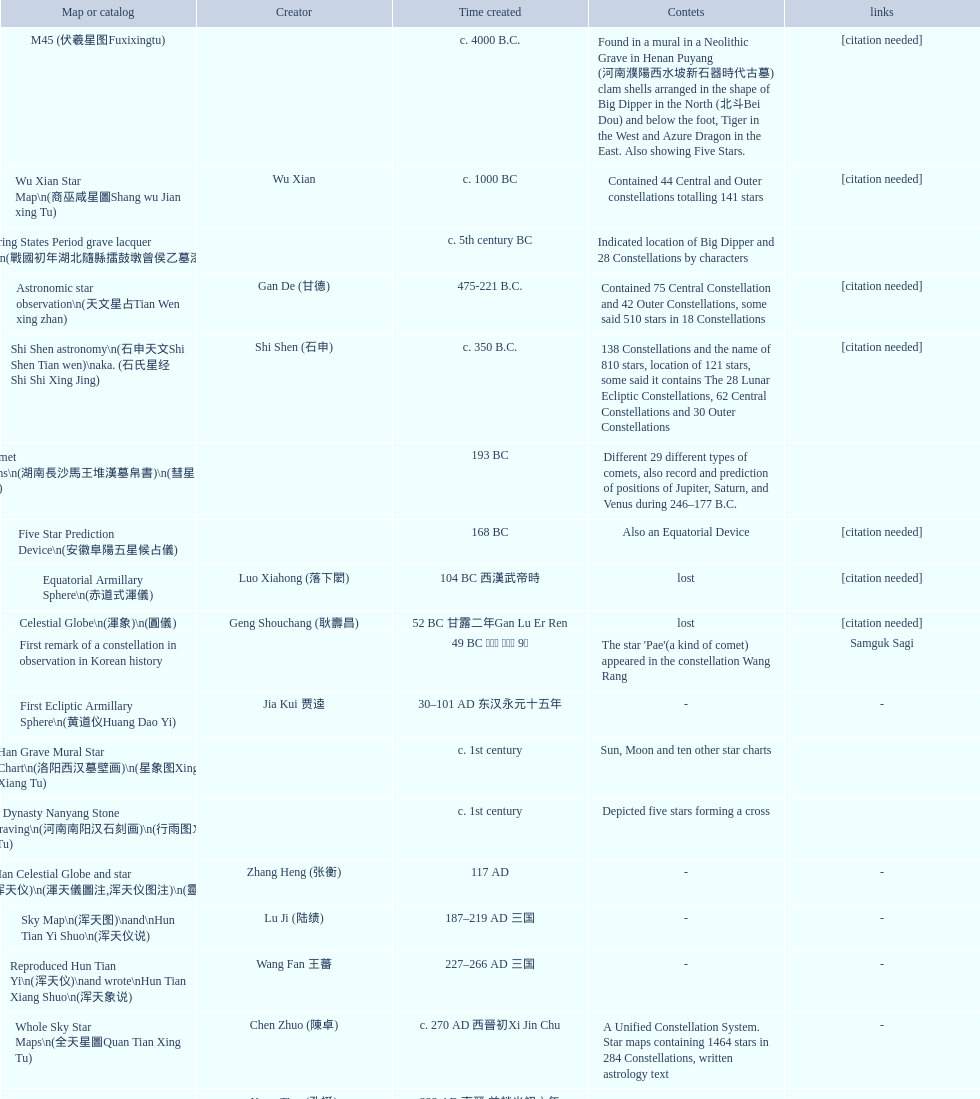Mention three products developed closely following the equatorial armillary sphere. Celestial Globe (渾象) (圓儀), First remark of a constellation in observation in Korean history, First Ecliptic Armillary Sphere (黄道仪Huang Dao Yi). 